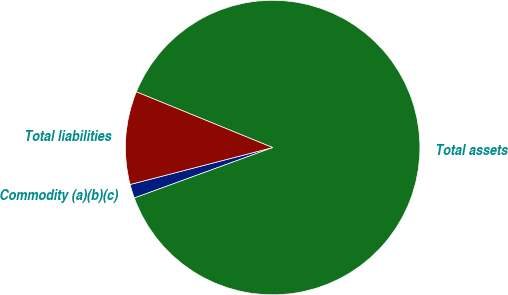<chart> <loc_0><loc_0><loc_500><loc_500><pie_chart><fcel>Commodity (a)(b)(c)<fcel>Total assets<fcel>Total liabilities<nl><fcel>1.53%<fcel>88.26%<fcel>10.21%<nl></chart> 